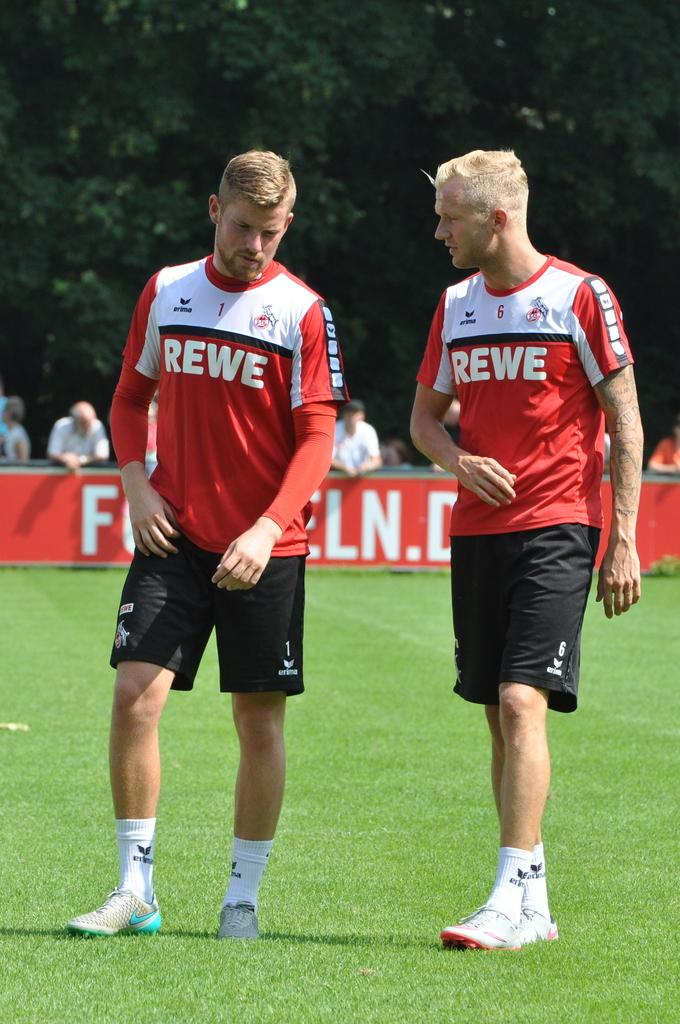<image>
Relay a brief, clear account of the picture shown. Two players from the REWE team converse as they walk on the field. 